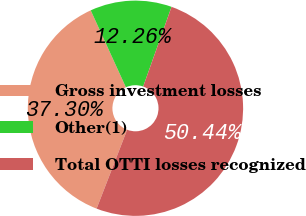<chart> <loc_0><loc_0><loc_500><loc_500><pie_chart><fcel>Gross investment losses<fcel>Other(1)<fcel>Total OTTI losses recognized<nl><fcel>37.3%<fcel>12.26%<fcel>50.44%<nl></chart> 